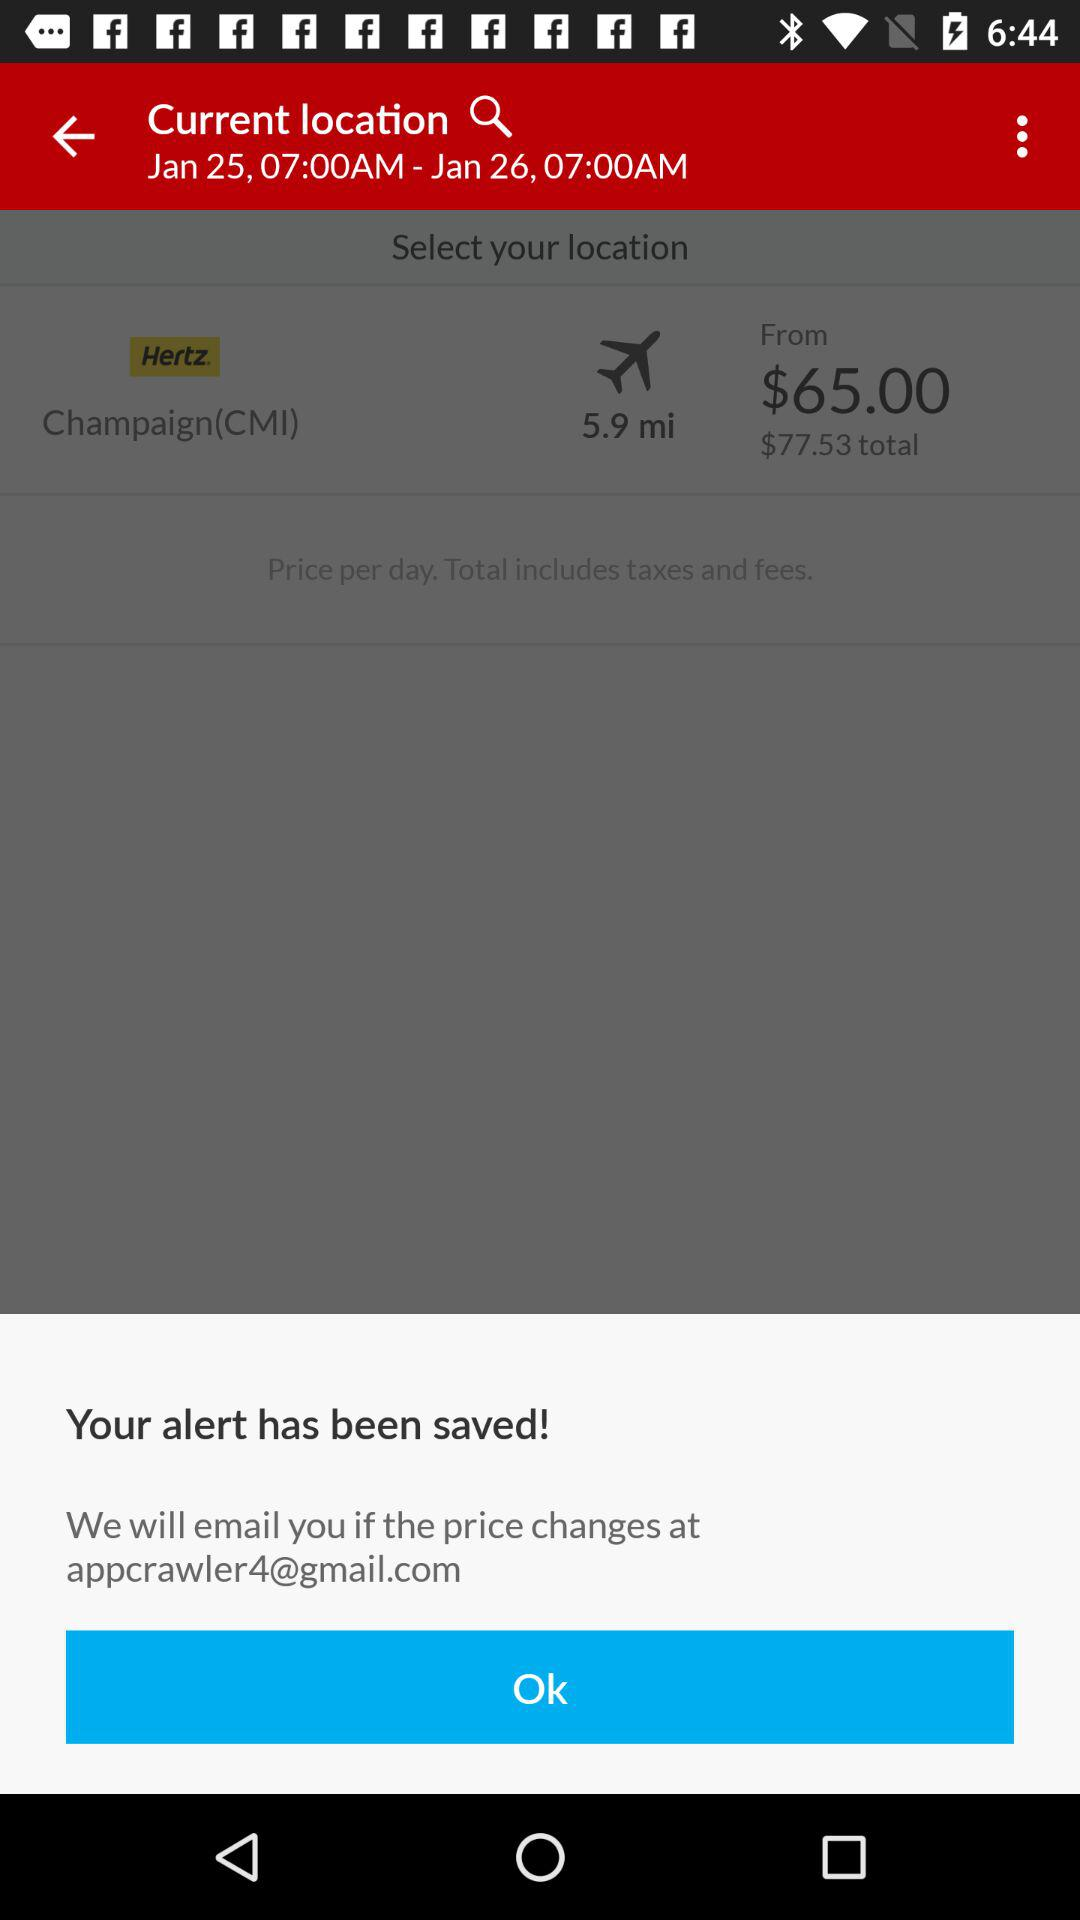What is the email address? The email address is appcrawler4@gmail.com. 